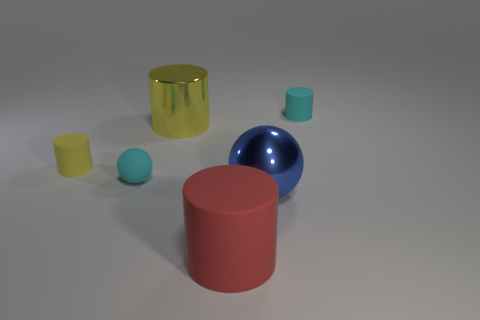Subtract all yellow metal cylinders. How many cylinders are left? 3 Add 4 small yellow cylinders. How many objects exist? 10 Subtract all cylinders. How many objects are left? 2 Subtract 2 spheres. How many spheres are left? 0 Subtract all yellow balls. How many yellow cylinders are left? 2 Subtract all large blue rubber things. Subtract all yellow metallic objects. How many objects are left? 5 Add 4 blue balls. How many blue balls are left? 5 Add 3 large cyan cubes. How many large cyan cubes exist? 3 Subtract all blue spheres. How many spheres are left? 1 Subtract 2 yellow cylinders. How many objects are left? 4 